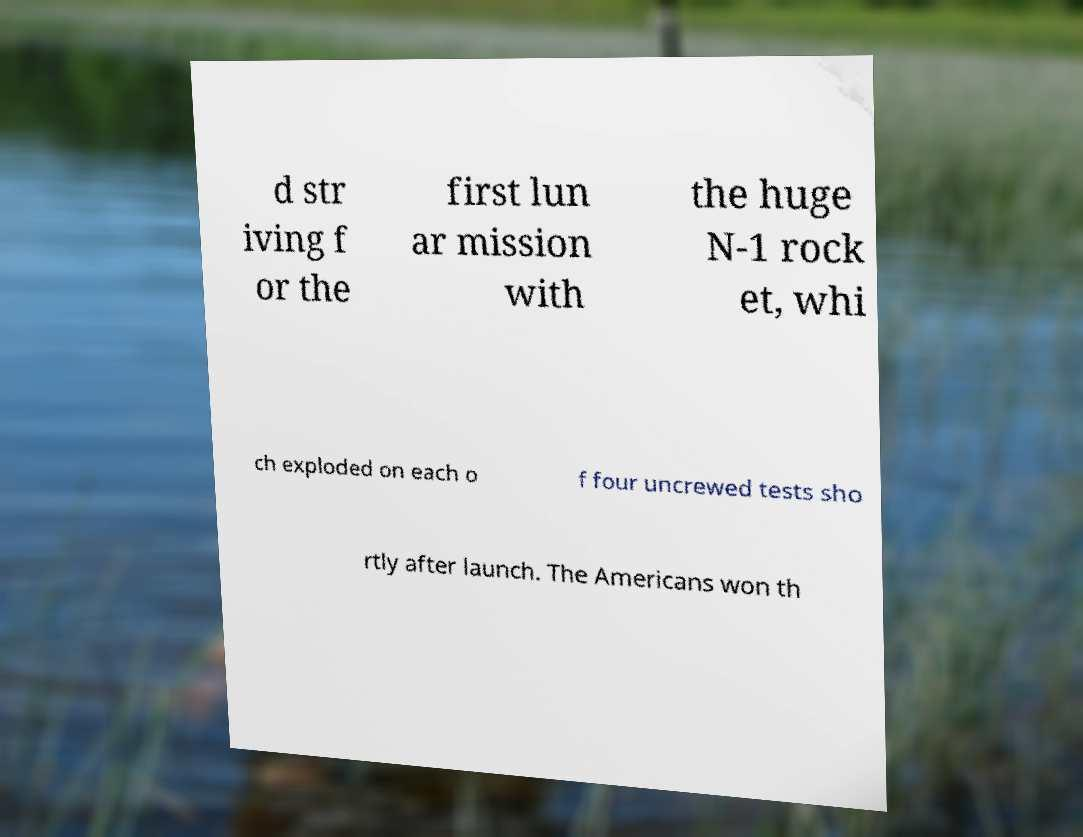There's text embedded in this image that I need extracted. Can you transcribe it verbatim? d str iving f or the first lun ar mission with the huge N-1 rock et, whi ch exploded on each o f four uncrewed tests sho rtly after launch. The Americans won th 